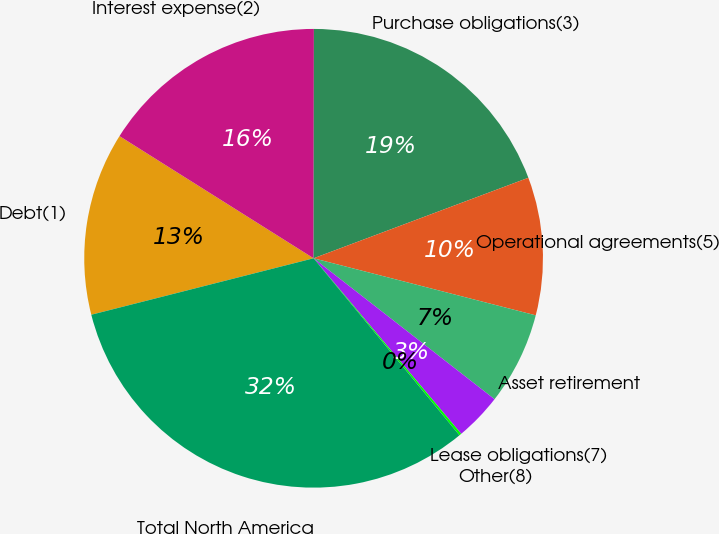Convert chart. <chart><loc_0><loc_0><loc_500><loc_500><pie_chart><fcel>Debt(1)<fcel>Interest expense(2)<fcel>Purchase obligations(3)<fcel>Operational agreements(5)<fcel>Asset retirement<fcel>Lease obligations(7)<fcel>Other(8)<fcel>Total North America<nl><fcel>12.9%<fcel>16.08%<fcel>19.27%<fcel>9.71%<fcel>6.53%<fcel>3.34%<fcel>0.16%<fcel>32.01%<nl></chart> 